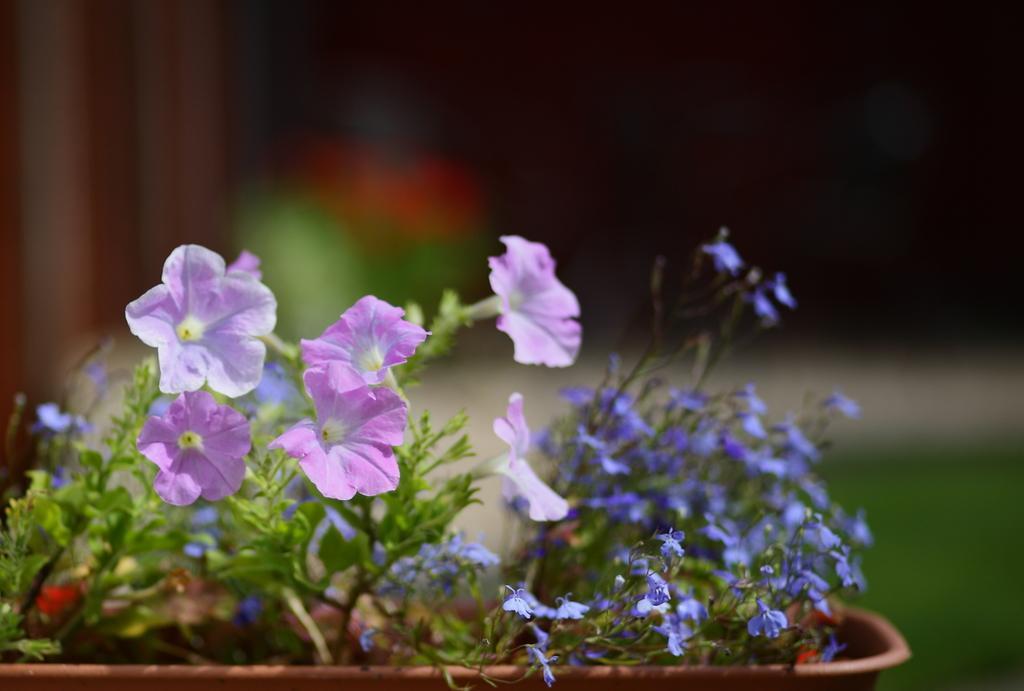How would you summarize this image in a sentence or two? In the foreground of the picture there is a flower pot, in it there are plants and flowers. The background is blurred. 